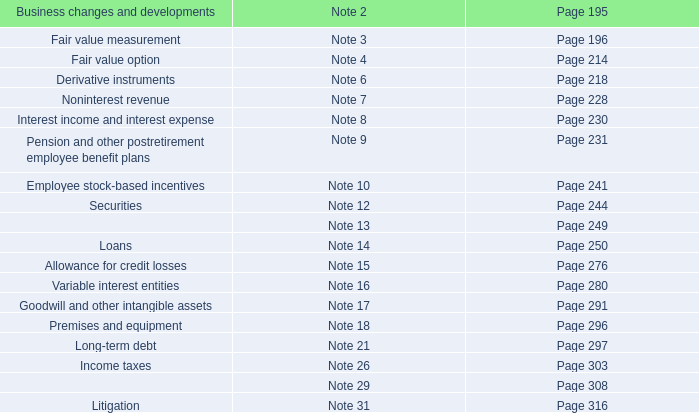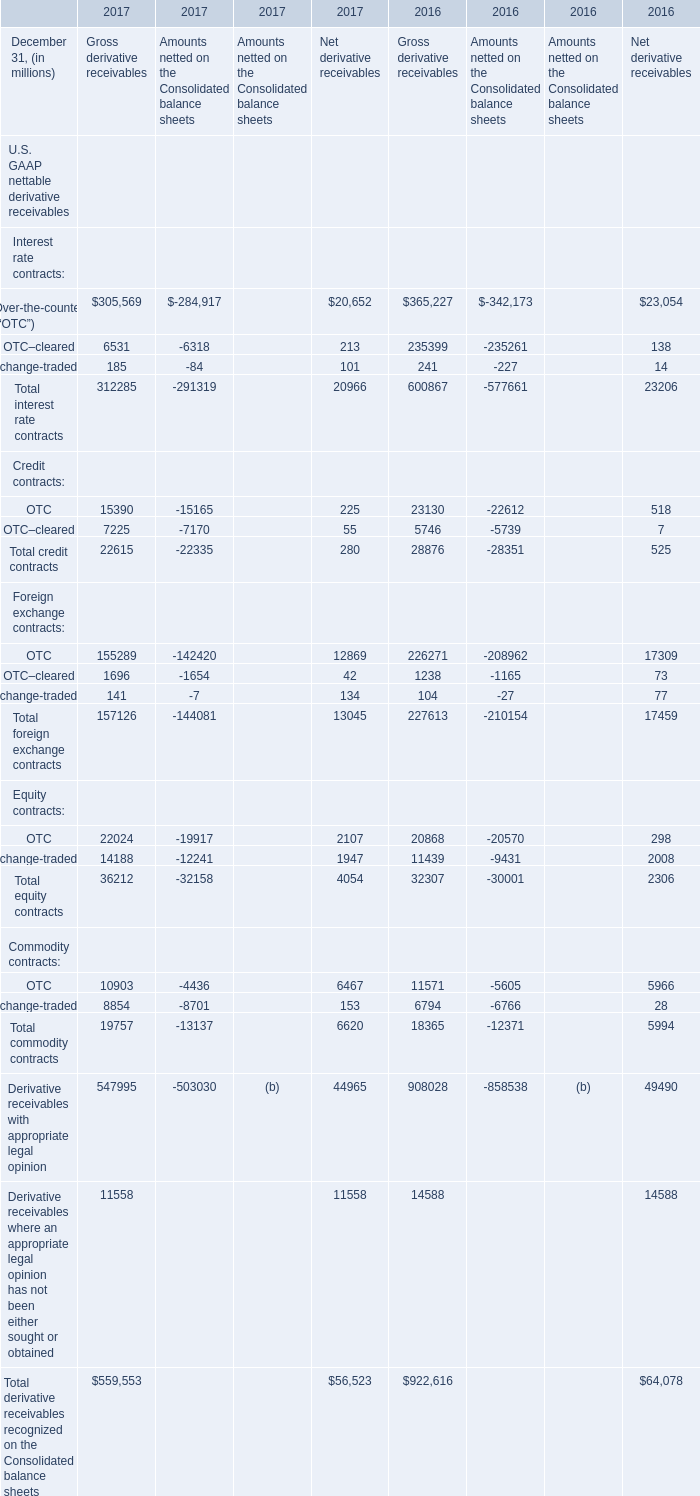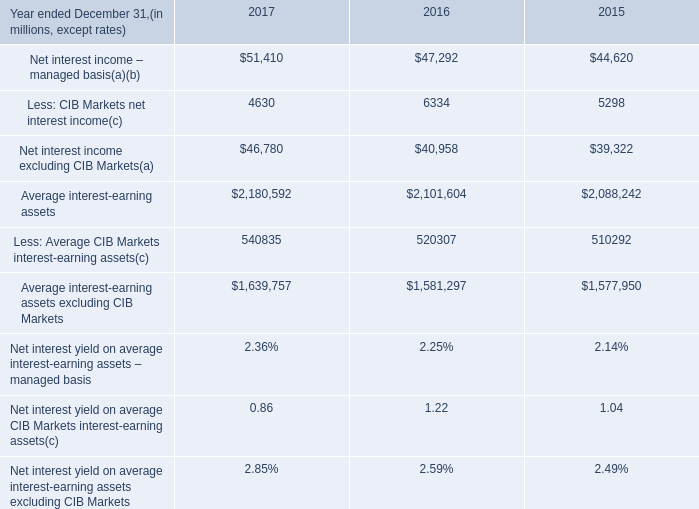Does the average value of OTC in 2017 greater than that in 2016? 
Answer: yes. 